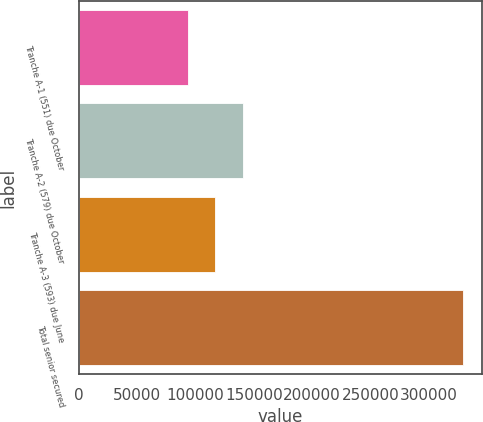Convert chart. <chart><loc_0><loc_0><loc_500><loc_500><bar_chart><fcel>Tranche A-1 (551) due October<fcel>Tranche A-2 (579) due October<fcel>Tranche A-3 (593) due June<fcel>Total senior secured<nl><fcel>93500<fcel>140700<fcel>117100<fcel>329500<nl></chart> 